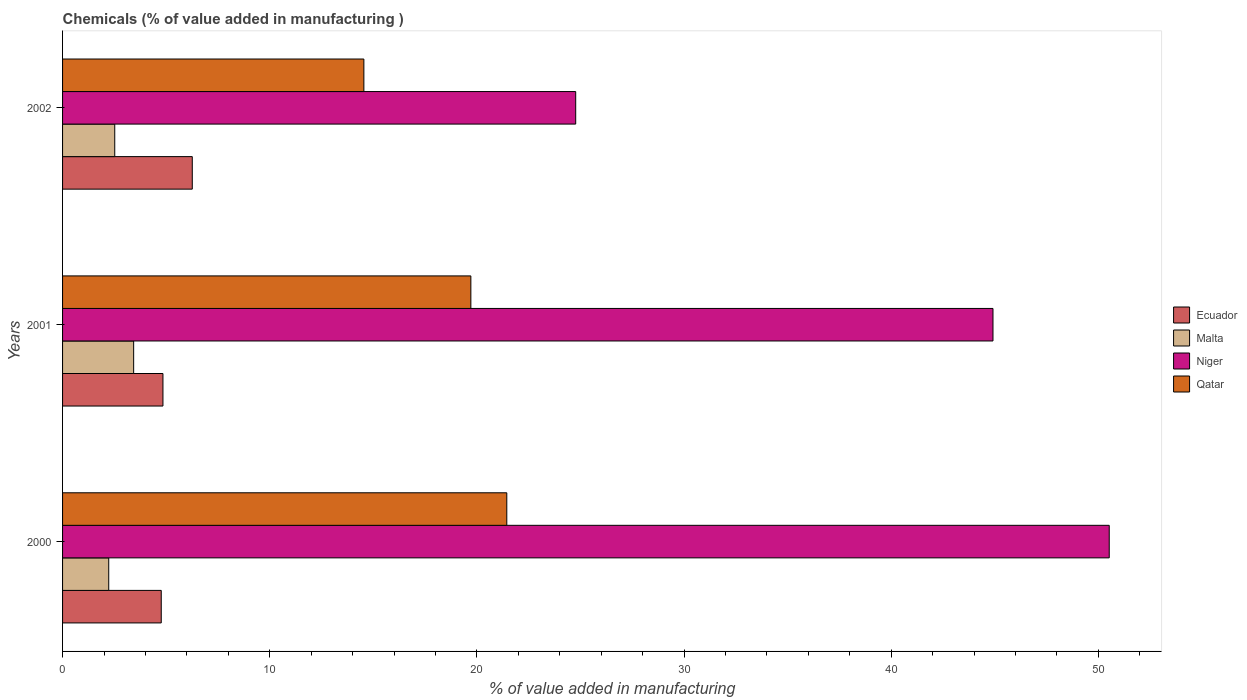How many different coloured bars are there?
Offer a terse response. 4. How many groups of bars are there?
Your answer should be very brief. 3. How many bars are there on the 2nd tick from the top?
Ensure brevity in your answer.  4. What is the value added in manufacturing chemicals in Qatar in 2001?
Ensure brevity in your answer.  19.71. Across all years, what is the maximum value added in manufacturing chemicals in Niger?
Give a very brief answer. 50.53. Across all years, what is the minimum value added in manufacturing chemicals in Malta?
Make the answer very short. 2.23. What is the total value added in manufacturing chemicals in Ecuador in the graph?
Your answer should be compact. 15.87. What is the difference between the value added in manufacturing chemicals in Qatar in 2000 and that in 2002?
Keep it short and to the point. 6.9. What is the difference between the value added in manufacturing chemicals in Malta in 2000 and the value added in manufacturing chemicals in Niger in 2001?
Provide a short and direct response. -42.69. What is the average value added in manufacturing chemicals in Ecuador per year?
Make the answer very short. 5.29. In the year 2001, what is the difference between the value added in manufacturing chemicals in Niger and value added in manufacturing chemicals in Qatar?
Your answer should be compact. 25.21. In how many years, is the value added in manufacturing chemicals in Niger greater than 4 %?
Offer a very short reply. 3. What is the ratio of the value added in manufacturing chemicals in Malta in 2001 to that in 2002?
Ensure brevity in your answer.  1.36. What is the difference between the highest and the second highest value added in manufacturing chemicals in Ecuador?
Provide a succinct answer. 1.42. What is the difference between the highest and the lowest value added in manufacturing chemicals in Ecuador?
Your response must be concise. 1.5. Is it the case that in every year, the sum of the value added in manufacturing chemicals in Ecuador and value added in manufacturing chemicals in Malta is greater than the sum of value added in manufacturing chemicals in Niger and value added in manufacturing chemicals in Qatar?
Keep it short and to the point. No. What does the 4th bar from the top in 2001 represents?
Your answer should be compact. Ecuador. What does the 4th bar from the bottom in 2000 represents?
Ensure brevity in your answer.  Qatar. How many years are there in the graph?
Ensure brevity in your answer.  3. Are the values on the major ticks of X-axis written in scientific E-notation?
Your answer should be compact. No. Where does the legend appear in the graph?
Your response must be concise. Center right. What is the title of the graph?
Your answer should be very brief. Chemicals (% of value added in manufacturing ). Does "Greece" appear as one of the legend labels in the graph?
Your response must be concise. No. What is the label or title of the X-axis?
Keep it short and to the point. % of value added in manufacturing. What is the % of value added in manufacturing of Ecuador in 2000?
Ensure brevity in your answer.  4.76. What is the % of value added in manufacturing of Malta in 2000?
Offer a terse response. 2.23. What is the % of value added in manufacturing of Niger in 2000?
Give a very brief answer. 50.53. What is the % of value added in manufacturing of Qatar in 2000?
Your response must be concise. 21.45. What is the % of value added in manufacturing of Ecuador in 2001?
Offer a terse response. 4.85. What is the % of value added in manufacturing of Malta in 2001?
Provide a short and direct response. 3.43. What is the % of value added in manufacturing of Niger in 2001?
Give a very brief answer. 44.92. What is the % of value added in manufacturing in Qatar in 2001?
Ensure brevity in your answer.  19.71. What is the % of value added in manufacturing in Ecuador in 2002?
Offer a terse response. 6.26. What is the % of value added in manufacturing in Malta in 2002?
Give a very brief answer. 2.52. What is the % of value added in manufacturing of Niger in 2002?
Give a very brief answer. 24.77. What is the % of value added in manufacturing in Qatar in 2002?
Make the answer very short. 14.55. Across all years, what is the maximum % of value added in manufacturing in Ecuador?
Provide a succinct answer. 6.26. Across all years, what is the maximum % of value added in manufacturing in Malta?
Your response must be concise. 3.43. Across all years, what is the maximum % of value added in manufacturing in Niger?
Provide a short and direct response. 50.53. Across all years, what is the maximum % of value added in manufacturing of Qatar?
Provide a succinct answer. 21.45. Across all years, what is the minimum % of value added in manufacturing of Ecuador?
Your answer should be compact. 4.76. Across all years, what is the minimum % of value added in manufacturing in Malta?
Your response must be concise. 2.23. Across all years, what is the minimum % of value added in manufacturing in Niger?
Your answer should be compact. 24.77. Across all years, what is the minimum % of value added in manufacturing in Qatar?
Offer a terse response. 14.55. What is the total % of value added in manufacturing of Ecuador in the graph?
Offer a very short reply. 15.87. What is the total % of value added in manufacturing in Malta in the graph?
Ensure brevity in your answer.  8.18. What is the total % of value added in manufacturing in Niger in the graph?
Your answer should be very brief. 120.22. What is the total % of value added in manufacturing in Qatar in the graph?
Make the answer very short. 55.7. What is the difference between the % of value added in manufacturing in Ecuador in 2000 and that in 2001?
Your response must be concise. -0.08. What is the difference between the % of value added in manufacturing of Malta in 2000 and that in 2001?
Ensure brevity in your answer.  -1.2. What is the difference between the % of value added in manufacturing in Niger in 2000 and that in 2001?
Provide a short and direct response. 5.61. What is the difference between the % of value added in manufacturing of Qatar in 2000 and that in 2001?
Your answer should be compact. 1.74. What is the difference between the % of value added in manufacturing of Ecuador in 2000 and that in 2002?
Keep it short and to the point. -1.5. What is the difference between the % of value added in manufacturing of Malta in 2000 and that in 2002?
Provide a succinct answer. -0.29. What is the difference between the % of value added in manufacturing in Niger in 2000 and that in 2002?
Your answer should be compact. 25.76. What is the difference between the % of value added in manufacturing of Qatar in 2000 and that in 2002?
Your answer should be very brief. 6.9. What is the difference between the % of value added in manufacturing of Ecuador in 2001 and that in 2002?
Ensure brevity in your answer.  -1.42. What is the difference between the % of value added in manufacturing in Malta in 2001 and that in 2002?
Offer a very short reply. 0.91. What is the difference between the % of value added in manufacturing of Niger in 2001 and that in 2002?
Keep it short and to the point. 20.14. What is the difference between the % of value added in manufacturing in Qatar in 2001 and that in 2002?
Keep it short and to the point. 5.16. What is the difference between the % of value added in manufacturing in Ecuador in 2000 and the % of value added in manufacturing in Malta in 2001?
Provide a succinct answer. 1.33. What is the difference between the % of value added in manufacturing of Ecuador in 2000 and the % of value added in manufacturing of Niger in 2001?
Your answer should be compact. -40.15. What is the difference between the % of value added in manufacturing of Ecuador in 2000 and the % of value added in manufacturing of Qatar in 2001?
Offer a very short reply. -14.95. What is the difference between the % of value added in manufacturing in Malta in 2000 and the % of value added in manufacturing in Niger in 2001?
Provide a succinct answer. -42.69. What is the difference between the % of value added in manufacturing of Malta in 2000 and the % of value added in manufacturing of Qatar in 2001?
Provide a short and direct response. -17.48. What is the difference between the % of value added in manufacturing in Niger in 2000 and the % of value added in manufacturing in Qatar in 2001?
Keep it short and to the point. 30.82. What is the difference between the % of value added in manufacturing in Ecuador in 2000 and the % of value added in manufacturing in Malta in 2002?
Provide a succinct answer. 2.24. What is the difference between the % of value added in manufacturing in Ecuador in 2000 and the % of value added in manufacturing in Niger in 2002?
Provide a short and direct response. -20.01. What is the difference between the % of value added in manufacturing in Ecuador in 2000 and the % of value added in manufacturing in Qatar in 2002?
Keep it short and to the point. -9.78. What is the difference between the % of value added in manufacturing of Malta in 2000 and the % of value added in manufacturing of Niger in 2002?
Provide a succinct answer. -22.54. What is the difference between the % of value added in manufacturing in Malta in 2000 and the % of value added in manufacturing in Qatar in 2002?
Provide a succinct answer. -12.32. What is the difference between the % of value added in manufacturing of Niger in 2000 and the % of value added in manufacturing of Qatar in 2002?
Offer a terse response. 35.98. What is the difference between the % of value added in manufacturing of Ecuador in 2001 and the % of value added in manufacturing of Malta in 2002?
Offer a very short reply. 2.33. What is the difference between the % of value added in manufacturing of Ecuador in 2001 and the % of value added in manufacturing of Niger in 2002?
Offer a very short reply. -19.93. What is the difference between the % of value added in manufacturing of Ecuador in 2001 and the % of value added in manufacturing of Qatar in 2002?
Your response must be concise. -9.7. What is the difference between the % of value added in manufacturing in Malta in 2001 and the % of value added in manufacturing in Niger in 2002?
Your response must be concise. -21.34. What is the difference between the % of value added in manufacturing of Malta in 2001 and the % of value added in manufacturing of Qatar in 2002?
Ensure brevity in your answer.  -11.11. What is the difference between the % of value added in manufacturing in Niger in 2001 and the % of value added in manufacturing in Qatar in 2002?
Your answer should be very brief. 30.37. What is the average % of value added in manufacturing of Ecuador per year?
Ensure brevity in your answer.  5.29. What is the average % of value added in manufacturing in Malta per year?
Your response must be concise. 2.73. What is the average % of value added in manufacturing of Niger per year?
Offer a terse response. 40.07. What is the average % of value added in manufacturing of Qatar per year?
Keep it short and to the point. 18.57. In the year 2000, what is the difference between the % of value added in manufacturing of Ecuador and % of value added in manufacturing of Malta?
Your answer should be very brief. 2.53. In the year 2000, what is the difference between the % of value added in manufacturing in Ecuador and % of value added in manufacturing in Niger?
Your answer should be compact. -45.76. In the year 2000, what is the difference between the % of value added in manufacturing in Ecuador and % of value added in manufacturing in Qatar?
Your response must be concise. -16.68. In the year 2000, what is the difference between the % of value added in manufacturing in Malta and % of value added in manufacturing in Niger?
Your response must be concise. -48.3. In the year 2000, what is the difference between the % of value added in manufacturing in Malta and % of value added in manufacturing in Qatar?
Offer a terse response. -19.22. In the year 2000, what is the difference between the % of value added in manufacturing in Niger and % of value added in manufacturing in Qatar?
Offer a terse response. 29.08. In the year 2001, what is the difference between the % of value added in manufacturing of Ecuador and % of value added in manufacturing of Malta?
Your answer should be very brief. 1.41. In the year 2001, what is the difference between the % of value added in manufacturing in Ecuador and % of value added in manufacturing in Niger?
Make the answer very short. -40.07. In the year 2001, what is the difference between the % of value added in manufacturing of Ecuador and % of value added in manufacturing of Qatar?
Make the answer very short. -14.86. In the year 2001, what is the difference between the % of value added in manufacturing in Malta and % of value added in manufacturing in Niger?
Ensure brevity in your answer.  -41.48. In the year 2001, what is the difference between the % of value added in manufacturing in Malta and % of value added in manufacturing in Qatar?
Offer a terse response. -16.28. In the year 2001, what is the difference between the % of value added in manufacturing of Niger and % of value added in manufacturing of Qatar?
Give a very brief answer. 25.21. In the year 2002, what is the difference between the % of value added in manufacturing in Ecuador and % of value added in manufacturing in Malta?
Your answer should be compact. 3.74. In the year 2002, what is the difference between the % of value added in manufacturing of Ecuador and % of value added in manufacturing of Niger?
Give a very brief answer. -18.51. In the year 2002, what is the difference between the % of value added in manufacturing in Ecuador and % of value added in manufacturing in Qatar?
Your response must be concise. -8.28. In the year 2002, what is the difference between the % of value added in manufacturing of Malta and % of value added in manufacturing of Niger?
Offer a very short reply. -22.25. In the year 2002, what is the difference between the % of value added in manufacturing of Malta and % of value added in manufacturing of Qatar?
Ensure brevity in your answer.  -12.03. In the year 2002, what is the difference between the % of value added in manufacturing in Niger and % of value added in manufacturing in Qatar?
Your answer should be compact. 10.23. What is the ratio of the % of value added in manufacturing of Ecuador in 2000 to that in 2001?
Provide a short and direct response. 0.98. What is the ratio of the % of value added in manufacturing of Malta in 2000 to that in 2001?
Give a very brief answer. 0.65. What is the ratio of the % of value added in manufacturing of Niger in 2000 to that in 2001?
Provide a short and direct response. 1.12. What is the ratio of the % of value added in manufacturing of Qatar in 2000 to that in 2001?
Provide a short and direct response. 1.09. What is the ratio of the % of value added in manufacturing in Ecuador in 2000 to that in 2002?
Give a very brief answer. 0.76. What is the ratio of the % of value added in manufacturing in Malta in 2000 to that in 2002?
Provide a short and direct response. 0.88. What is the ratio of the % of value added in manufacturing of Niger in 2000 to that in 2002?
Give a very brief answer. 2.04. What is the ratio of the % of value added in manufacturing in Qatar in 2000 to that in 2002?
Offer a very short reply. 1.47. What is the ratio of the % of value added in manufacturing of Ecuador in 2001 to that in 2002?
Make the answer very short. 0.77. What is the ratio of the % of value added in manufacturing in Malta in 2001 to that in 2002?
Your response must be concise. 1.36. What is the ratio of the % of value added in manufacturing of Niger in 2001 to that in 2002?
Make the answer very short. 1.81. What is the ratio of the % of value added in manufacturing of Qatar in 2001 to that in 2002?
Your response must be concise. 1.35. What is the difference between the highest and the second highest % of value added in manufacturing of Ecuador?
Give a very brief answer. 1.42. What is the difference between the highest and the second highest % of value added in manufacturing of Malta?
Provide a succinct answer. 0.91. What is the difference between the highest and the second highest % of value added in manufacturing of Niger?
Provide a succinct answer. 5.61. What is the difference between the highest and the second highest % of value added in manufacturing in Qatar?
Ensure brevity in your answer.  1.74. What is the difference between the highest and the lowest % of value added in manufacturing in Ecuador?
Make the answer very short. 1.5. What is the difference between the highest and the lowest % of value added in manufacturing in Malta?
Offer a terse response. 1.2. What is the difference between the highest and the lowest % of value added in manufacturing of Niger?
Give a very brief answer. 25.76. What is the difference between the highest and the lowest % of value added in manufacturing of Qatar?
Your answer should be compact. 6.9. 